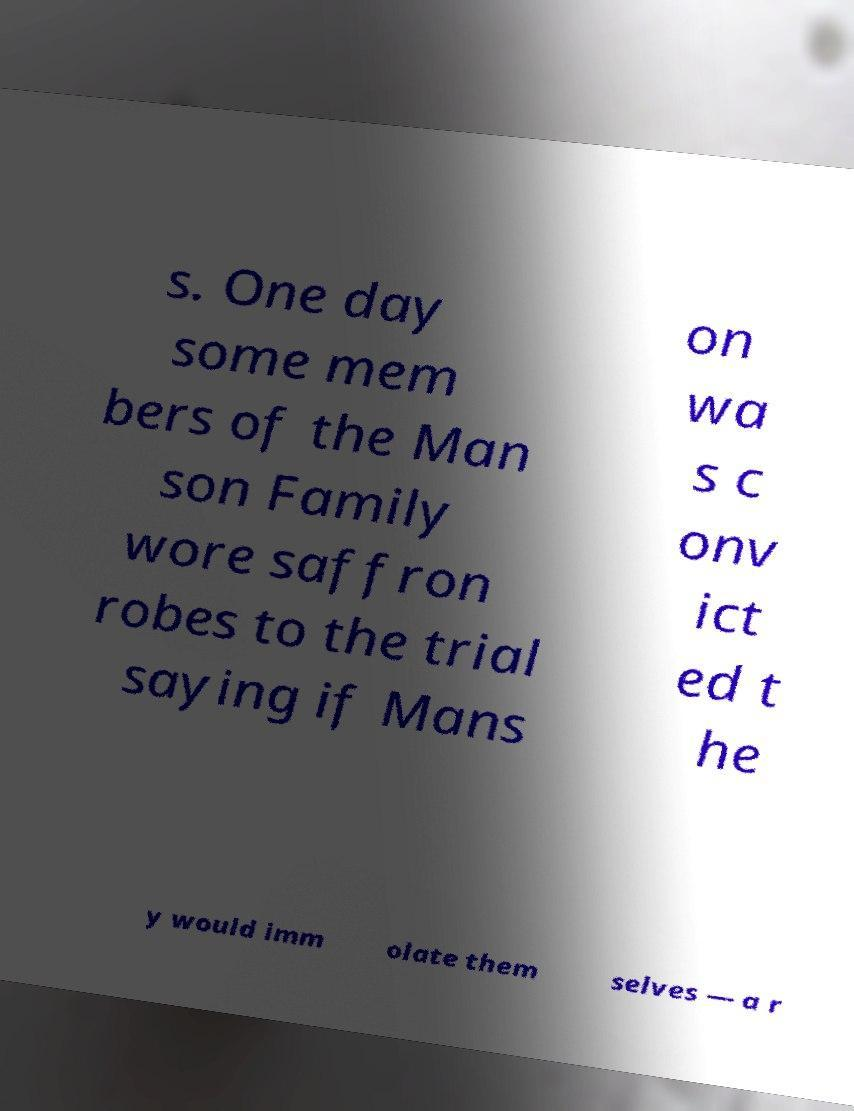Please identify and transcribe the text found in this image. s. One day some mem bers of the Man son Family wore saffron robes to the trial saying if Mans on wa s c onv ict ed t he y would imm olate them selves — a r 